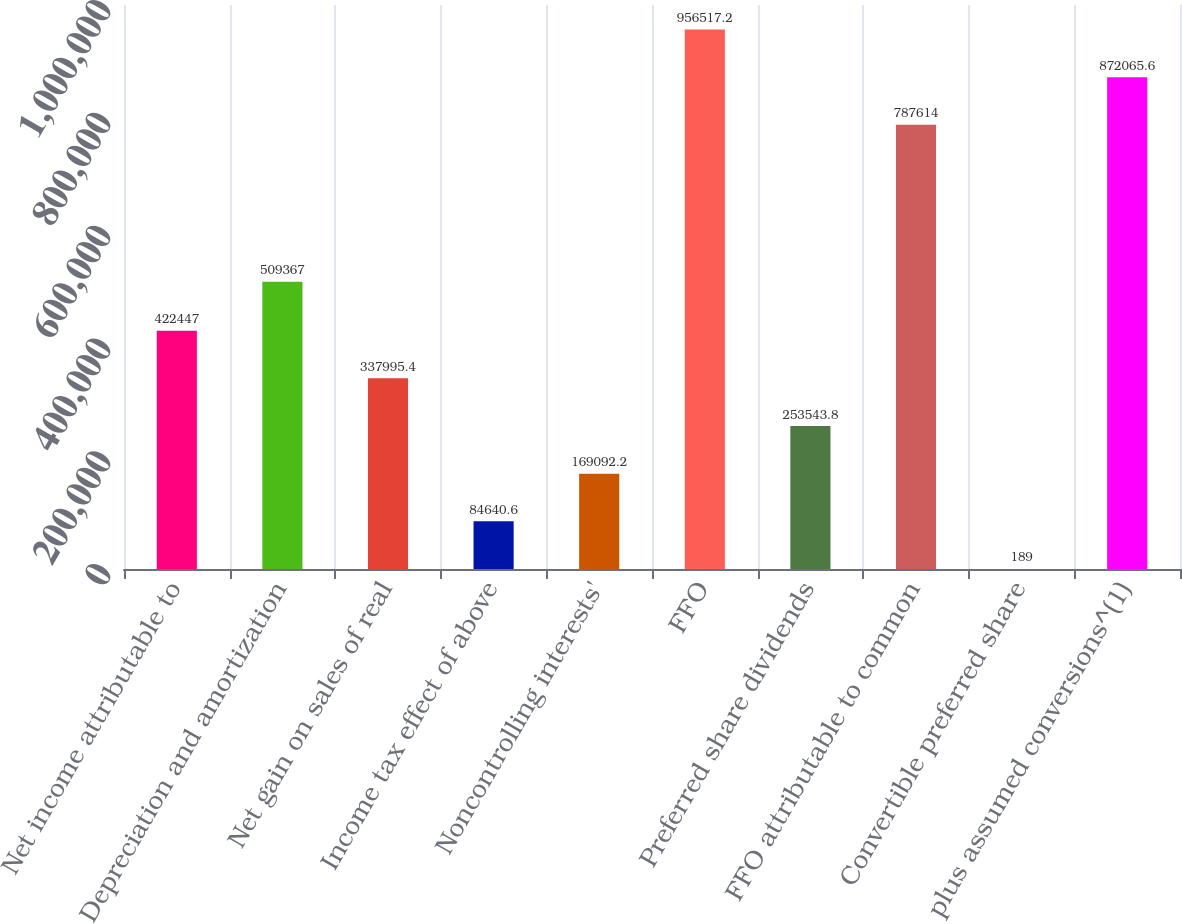Convert chart. <chart><loc_0><loc_0><loc_500><loc_500><bar_chart><fcel>Net income attributable to<fcel>Depreciation and amortization<fcel>Net gain on sales of real<fcel>Income tax effect of above<fcel>Noncontrolling interests'<fcel>FFO<fcel>Preferred share dividends<fcel>FFO attributable to common<fcel>Convertible preferred share<fcel>plus assumed conversions^(1)<nl><fcel>422447<fcel>509367<fcel>337995<fcel>84640.6<fcel>169092<fcel>956517<fcel>253544<fcel>787614<fcel>189<fcel>872066<nl></chart> 